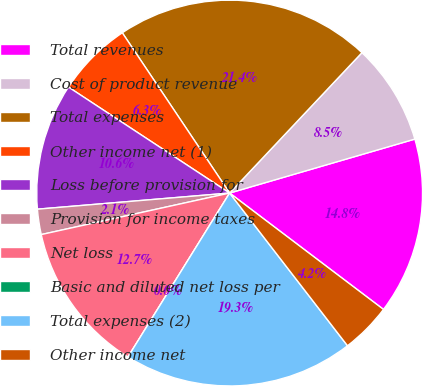<chart> <loc_0><loc_0><loc_500><loc_500><pie_chart><fcel>Total revenues<fcel>Cost of product revenue<fcel>Total expenses<fcel>Other income net (1)<fcel>Loss before provision for<fcel>Provision for income taxes<fcel>Net loss<fcel>Basic and diluted net loss per<fcel>Total expenses (2)<fcel>Other income net<nl><fcel>14.82%<fcel>8.46%<fcel>21.42%<fcel>6.35%<fcel>10.59%<fcel>2.12%<fcel>12.71%<fcel>0.0%<fcel>19.3%<fcel>4.23%<nl></chart> 